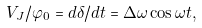Convert formula to latex. <formula><loc_0><loc_0><loc_500><loc_500>V _ { J } / \varphi _ { 0 } = d \delta / d t = \Delta \omega \cos \omega t ,</formula> 